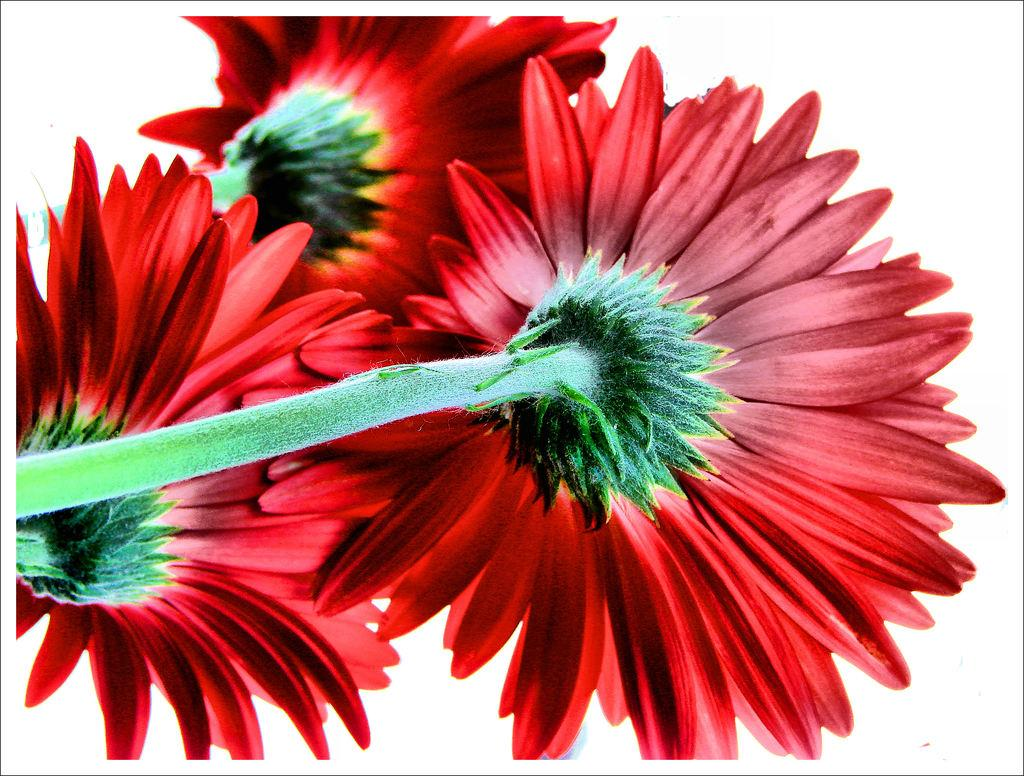What type of living organisms can be seen in the image? There are flowers with stems in the image. What is the color of the background in the image? The background of the image is white. What type of food is being prepared in the image? There is no food preparation visible in the image; it features flowers with stems against a white background. Can you tell me how many yaks are present in the image? There are no yaks present in the image. 